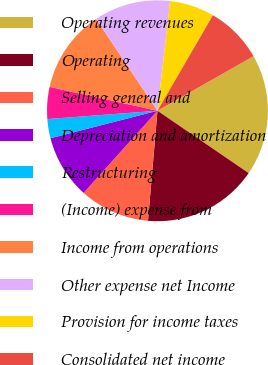Convert chart to OTSL. <chart><loc_0><loc_0><loc_500><loc_500><pie_chart><fcel>Operating revenues<fcel>Operating<fcel>Selling general and<fcel>Depreciation and amortization<fcel>Restructuring<fcel>(Income) expense from<fcel>Income from operations<fcel>Other expense net Income<fcel>Provision for income taxes<fcel>Consolidated net income<nl><fcel>17.76%<fcel>16.82%<fcel>10.28%<fcel>9.35%<fcel>2.8%<fcel>4.67%<fcel>12.15%<fcel>11.21%<fcel>6.54%<fcel>8.41%<nl></chart> 